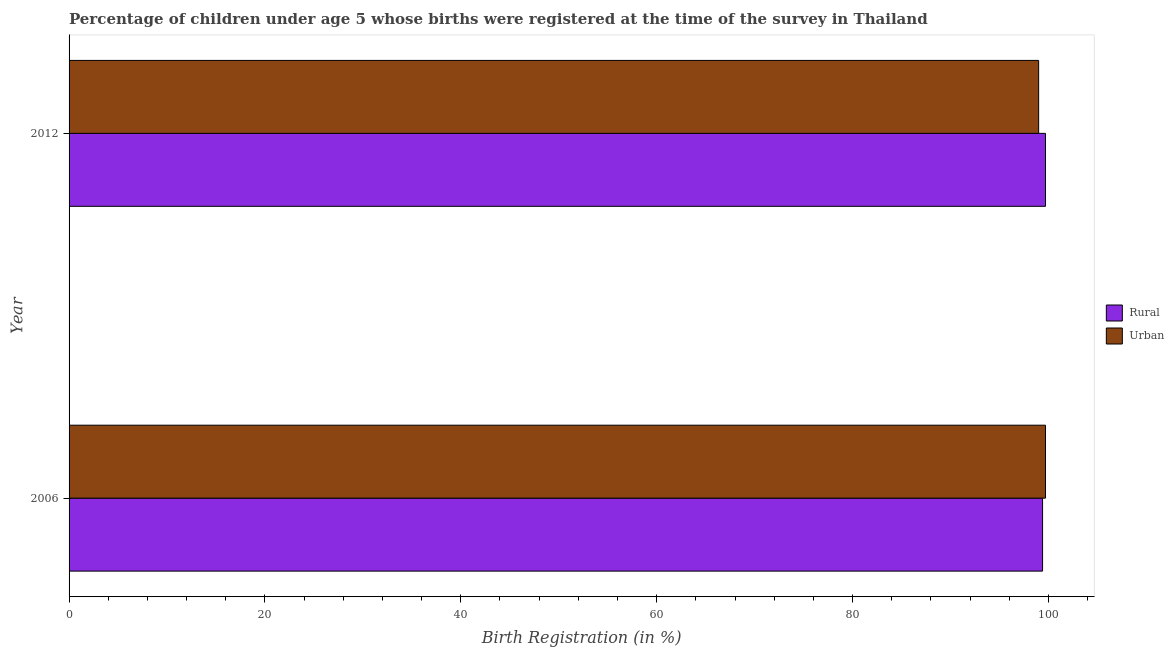How many different coloured bars are there?
Ensure brevity in your answer.  2. How many groups of bars are there?
Your answer should be compact. 2. How many bars are there on the 2nd tick from the top?
Offer a very short reply. 2. How many bars are there on the 2nd tick from the bottom?
Offer a very short reply. 2. What is the rural birth registration in 2006?
Provide a short and direct response. 99.4. Across all years, what is the maximum urban birth registration?
Offer a terse response. 99.7. Across all years, what is the minimum rural birth registration?
Provide a succinct answer. 99.4. What is the total urban birth registration in the graph?
Keep it short and to the point. 198.7. What is the difference between the rural birth registration in 2006 and that in 2012?
Offer a very short reply. -0.3. What is the difference between the urban birth registration in 2006 and the rural birth registration in 2012?
Provide a succinct answer. 0. What is the average urban birth registration per year?
Your response must be concise. 99.35. In the year 2012, what is the difference between the urban birth registration and rural birth registration?
Provide a succinct answer. -0.7. In how many years, is the urban birth registration greater than 92 %?
Your answer should be very brief. 2. What does the 1st bar from the top in 2006 represents?
Offer a very short reply. Urban. What does the 1st bar from the bottom in 2012 represents?
Give a very brief answer. Rural. How many bars are there?
Provide a succinct answer. 4. Are all the bars in the graph horizontal?
Provide a succinct answer. Yes. How many years are there in the graph?
Make the answer very short. 2. What is the difference between two consecutive major ticks on the X-axis?
Make the answer very short. 20. Are the values on the major ticks of X-axis written in scientific E-notation?
Make the answer very short. No. Does the graph contain grids?
Your answer should be compact. No. How many legend labels are there?
Offer a very short reply. 2. What is the title of the graph?
Offer a very short reply. Percentage of children under age 5 whose births were registered at the time of the survey in Thailand. What is the label or title of the X-axis?
Keep it short and to the point. Birth Registration (in %). What is the label or title of the Y-axis?
Your answer should be compact. Year. What is the Birth Registration (in %) in Rural in 2006?
Your response must be concise. 99.4. What is the Birth Registration (in %) in Urban in 2006?
Give a very brief answer. 99.7. What is the Birth Registration (in %) in Rural in 2012?
Ensure brevity in your answer.  99.7. What is the Birth Registration (in %) of Urban in 2012?
Provide a succinct answer. 99. Across all years, what is the maximum Birth Registration (in %) of Rural?
Your answer should be very brief. 99.7. Across all years, what is the maximum Birth Registration (in %) in Urban?
Your response must be concise. 99.7. Across all years, what is the minimum Birth Registration (in %) of Rural?
Provide a short and direct response. 99.4. Across all years, what is the minimum Birth Registration (in %) of Urban?
Your answer should be very brief. 99. What is the total Birth Registration (in %) of Rural in the graph?
Make the answer very short. 199.1. What is the total Birth Registration (in %) in Urban in the graph?
Keep it short and to the point. 198.7. What is the difference between the Birth Registration (in %) of Rural in 2006 and the Birth Registration (in %) of Urban in 2012?
Provide a succinct answer. 0.4. What is the average Birth Registration (in %) of Rural per year?
Ensure brevity in your answer.  99.55. What is the average Birth Registration (in %) of Urban per year?
Your answer should be compact. 99.35. In the year 2012, what is the difference between the Birth Registration (in %) of Rural and Birth Registration (in %) of Urban?
Keep it short and to the point. 0.7. What is the ratio of the Birth Registration (in %) in Urban in 2006 to that in 2012?
Provide a short and direct response. 1.01. What is the difference between the highest and the lowest Birth Registration (in %) in Urban?
Make the answer very short. 0.7. 